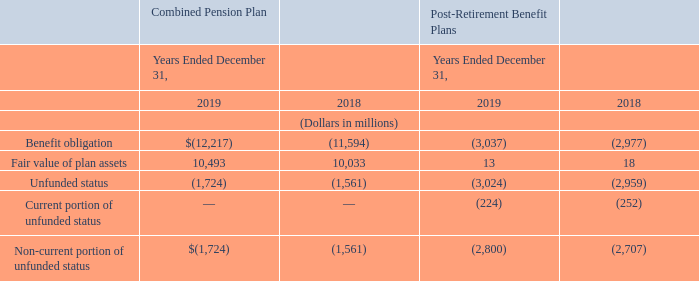Unfunded Status
The following table presents the unfunded status of the Combined Pension Plan and post-retirement benefit plans:
The current portion of our post-retirement benefit obligations is recorded on our consolidated balance sheets in accrued expenses and other current liabilities-salaries and benefits.
Where is the current portion of the post-retirement benefit obligations recorded? Recorded on our consolidated balance sheets in accrued expenses and other current liabilities-salaries and benefits. What is the fair value of plan assets for the combined pension plan item in 2019?
Answer scale should be: million. 10,493. The unfunded statuses of which items are presented in the table? Combined pension plan, post-retirement benefit plans. In which year is the fair value of plan assets under post-retirement benefit plans higher? 18>13
Answer: 2018. What is the difference in the fair value of plan assets under the combined pension plan in 2019?
Answer scale should be: million. 10,493-10,033
Answer: 460. What is the percentage difference in the fair value of plan assets under the combined pension plan in 2019?
Answer scale should be: percent. (10,493-10,033)/10,033
Answer: 4.58. 